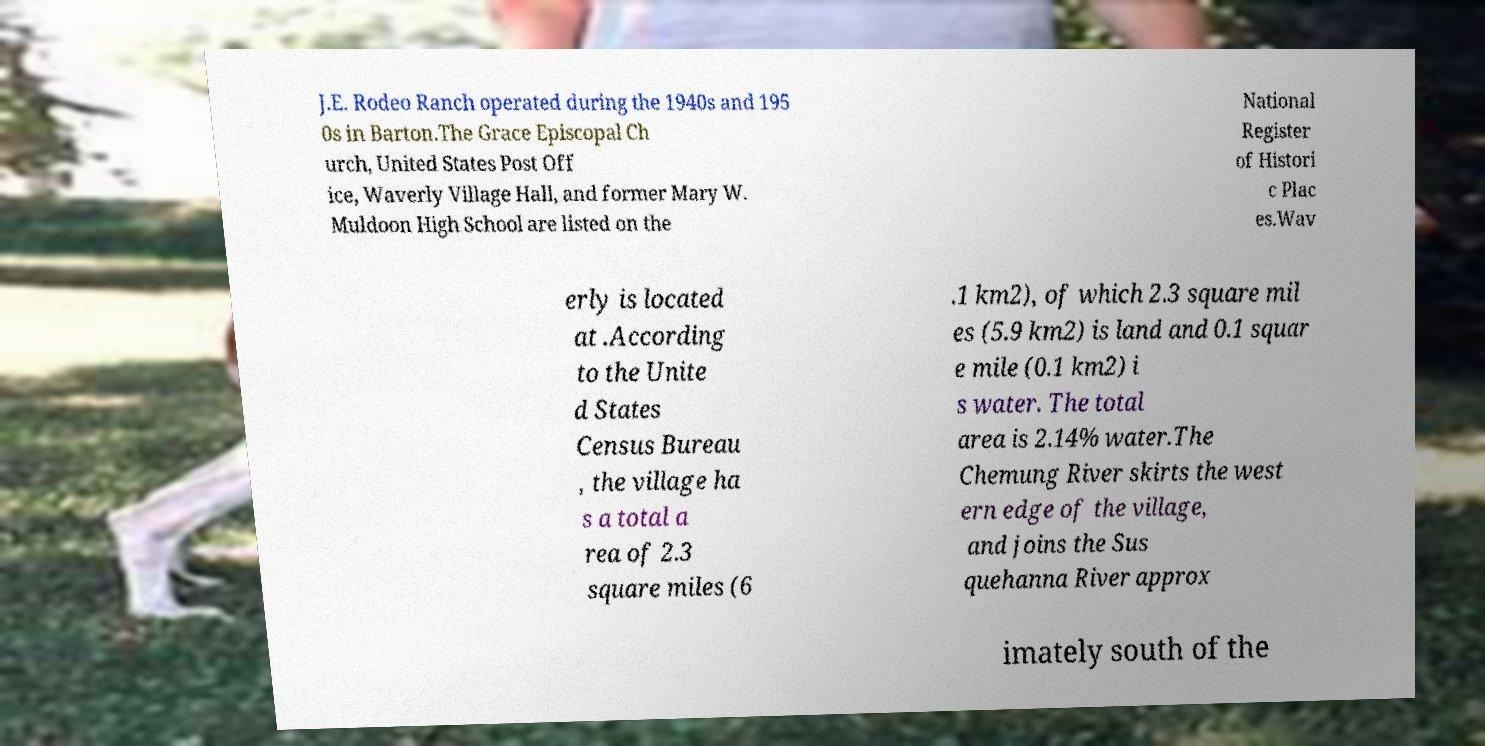Can you accurately transcribe the text from the provided image for me? J.E. Rodeo Ranch operated during the 1940s and 195 0s in Barton.The Grace Episcopal Ch urch, United States Post Off ice, Waverly Village Hall, and former Mary W. Muldoon High School are listed on the National Register of Histori c Plac es.Wav erly is located at .According to the Unite d States Census Bureau , the village ha s a total a rea of 2.3 square miles (6 .1 km2), of which 2.3 square mil es (5.9 km2) is land and 0.1 squar e mile (0.1 km2) i s water. The total area is 2.14% water.The Chemung River skirts the west ern edge of the village, and joins the Sus quehanna River approx imately south of the 